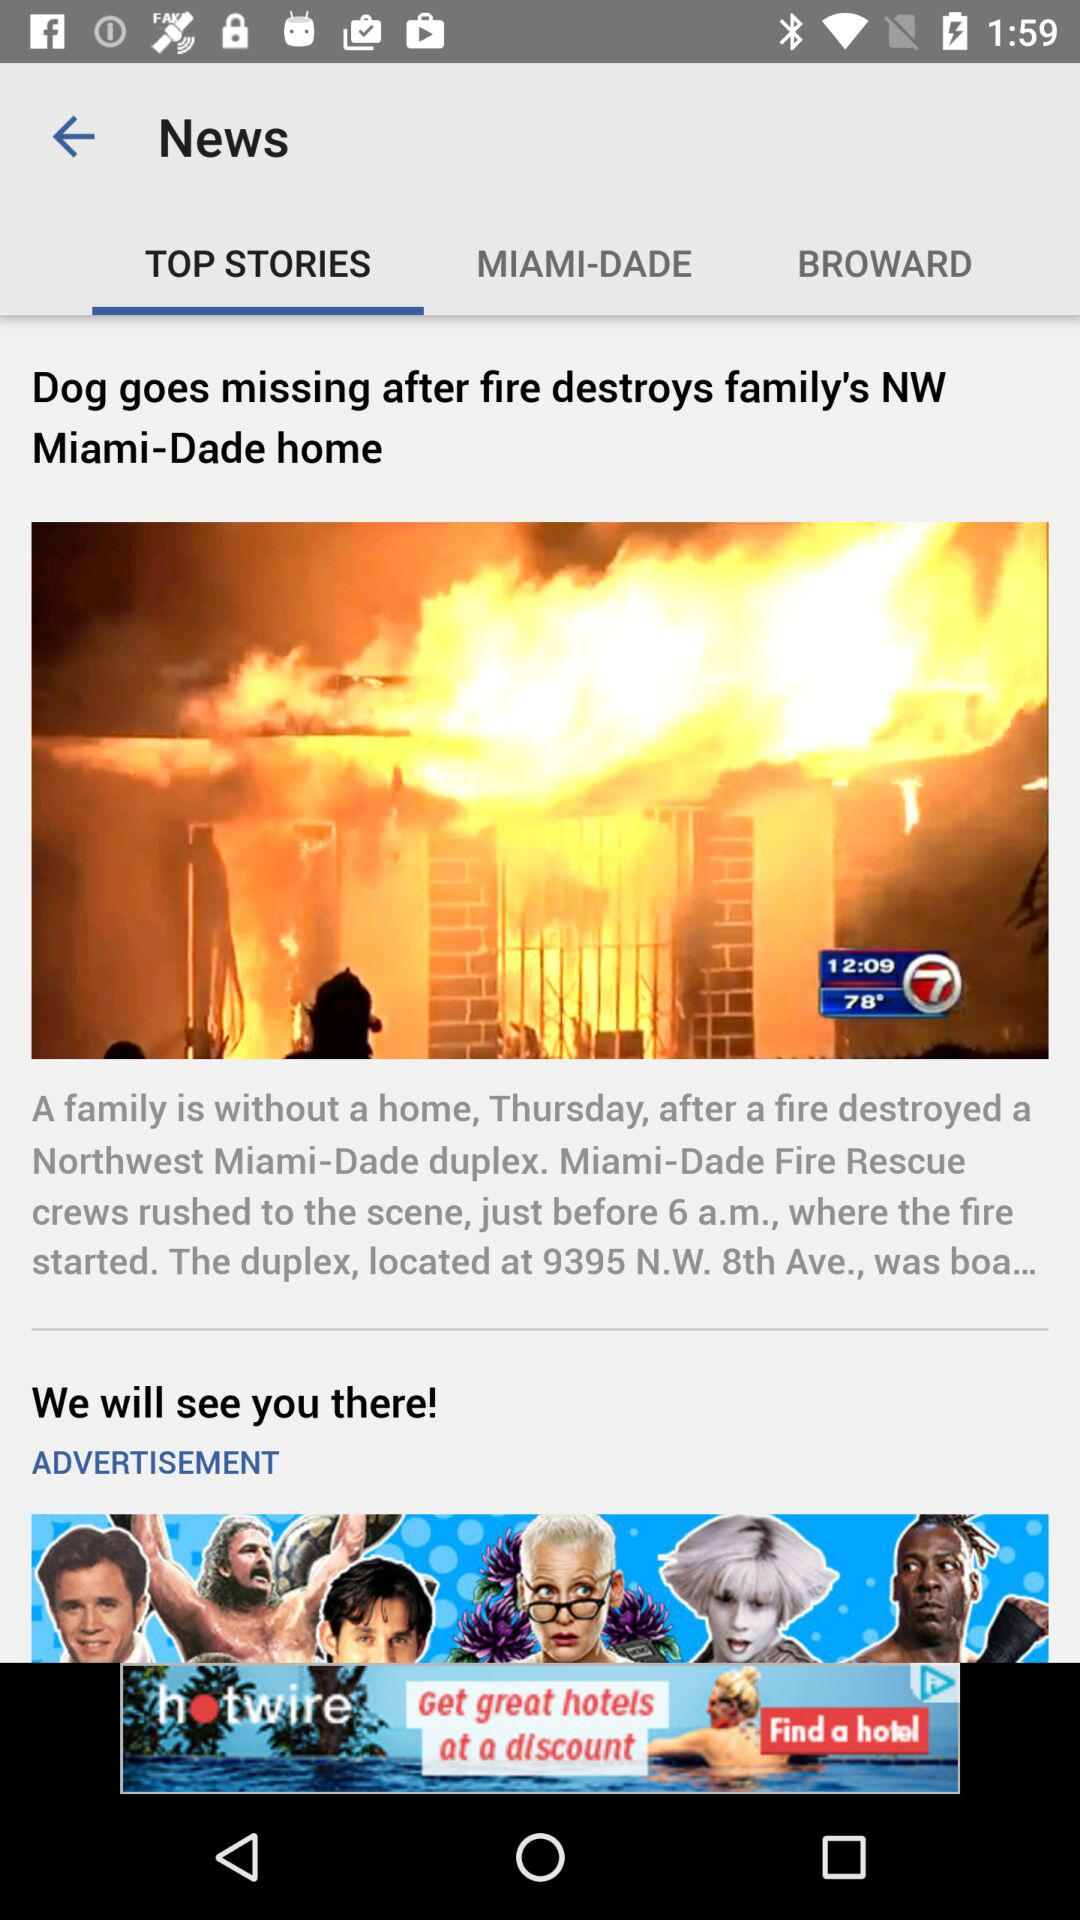What is the title of the news displayed? The title of the news displayed is "Dog goes missing after fire destroys family's NW Miami-Dade home". 